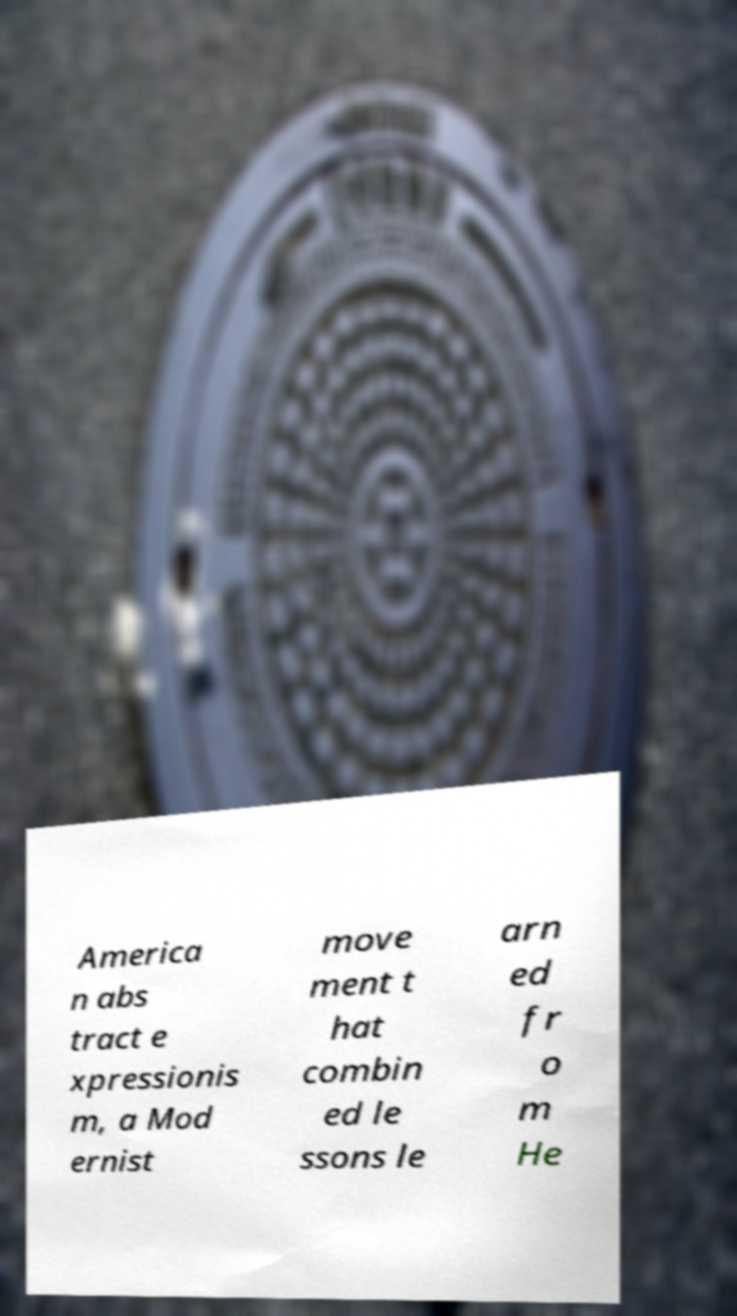There's text embedded in this image that I need extracted. Can you transcribe it verbatim? America n abs tract e xpressionis m, a Mod ernist move ment t hat combin ed le ssons le arn ed fr o m He 